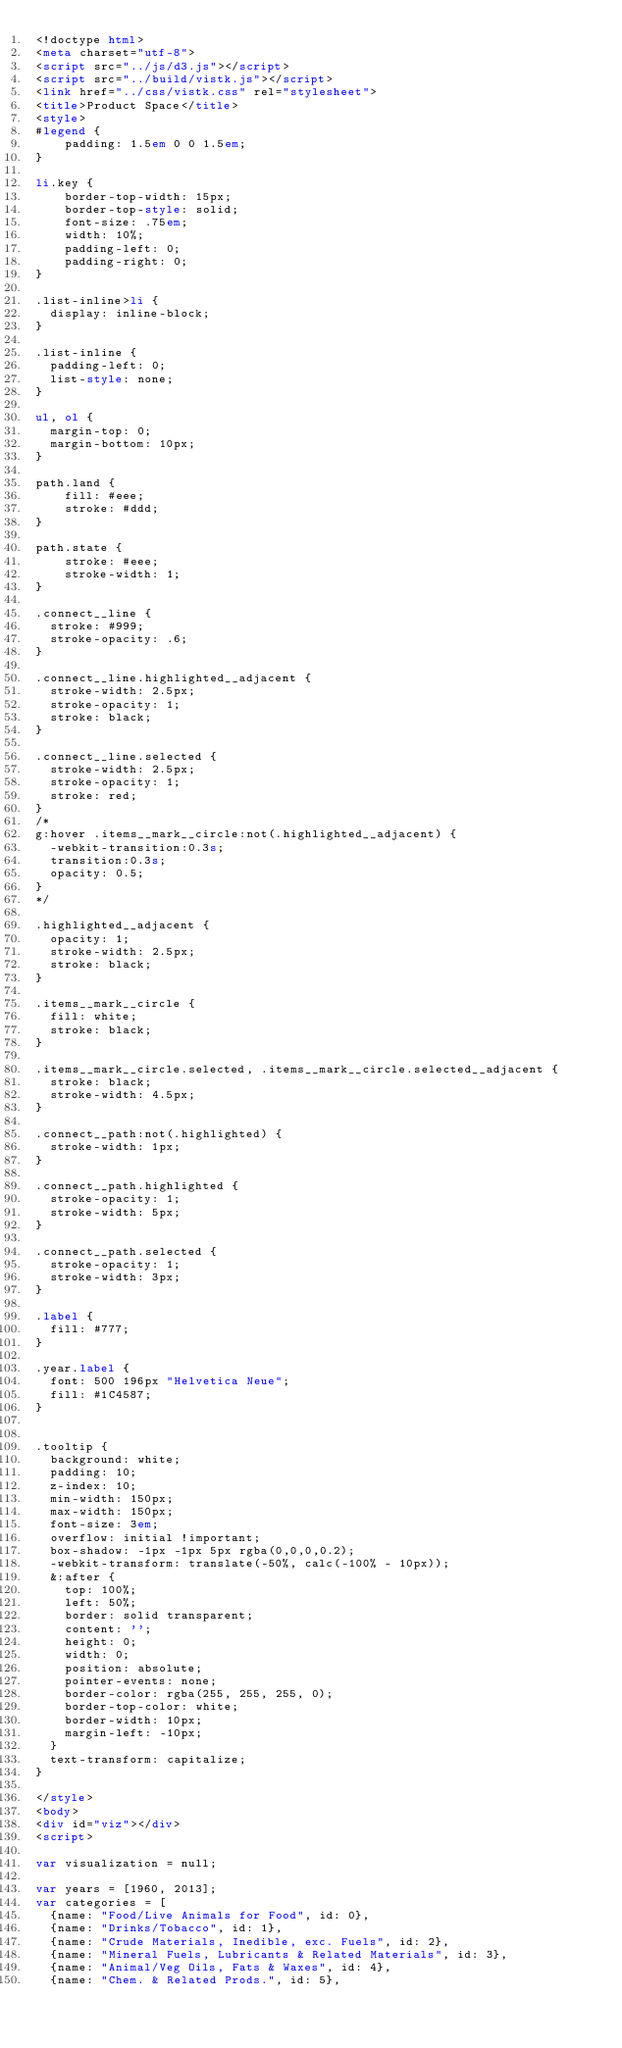Convert code to text. <code><loc_0><loc_0><loc_500><loc_500><_HTML_><!doctype html>
<meta charset="utf-8">
<script src="../js/d3.js"></script>
<script src="../build/vistk.js"></script>
<link href="../css/vistk.css" rel="stylesheet">
<title>Product Space</title>
<style>
#legend {
    padding: 1.5em 0 0 1.5em;
}

li.key {
    border-top-width: 15px;
    border-top-style: solid;
    font-size: .75em;
    width: 10%;
    padding-left: 0;
    padding-right: 0;
}

.list-inline>li {
  display: inline-block;
}

.list-inline {
  padding-left: 0;
  list-style: none;
}

ul, ol {
  margin-top: 0;
  margin-bottom: 10px;
}

path.land {
    fill: #eee;
    stroke: #ddd;
}

path.state {
    stroke: #eee;
    stroke-width: 1;
}

.connect__line {
  stroke: #999;
  stroke-opacity: .6;
}

.connect__line.highlighted__adjacent {
  stroke-width: 2.5px;
  stroke-opacity: 1;
  stroke: black;
}

.connect__line.selected {
  stroke-width: 2.5px;
  stroke-opacity: 1;
  stroke: red;
}
/*
g:hover .items__mark__circle:not(.highlighted__adjacent) {
  -webkit-transition:0.3s;
  transition:0.3s;
  opacity: 0.5;
}
*/

.highlighted__adjacent {
  opacity: 1;
  stroke-width: 2.5px;
  stroke: black;
}

.items__mark__circle {
  fill: white;
  stroke: black;
}

.items__mark__circle.selected, .items__mark__circle.selected__adjacent {
  stroke: black;
  stroke-width: 4.5px;
}

.connect__path:not(.highlighted) {
  stroke-width: 1px;
}

.connect__path.highlighted {
  stroke-opacity: 1;
  stroke-width: 5px;
}

.connect__path.selected {
  stroke-opacity: 1;
  stroke-width: 3px;
}

.label {
  fill: #777;
}

.year.label {
  font: 500 196px "Helvetica Neue";
  fill: #1C4587;
}


.tooltip {
  background: white;
  padding: 10;
  z-index: 10;
  min-width: 150px;
  max-width: 150px;
  font-size: 3em;
  overflow: initial !important;
  box-shadow: -1px -1px 5px rgba(0,0,0,0.2);
  -webkit-transform: translate(-50%, calc(-100% - 10px));
  &:after {
    top: 100%;
    left: 50%;
    border: solid transparent;
    content: '';
    height: 0;
    width: 0;
    position: absolute;
    pointer-events: none;
    border-color: rgba(255, 255, 255, 0);
    border-top-color: white;
    border-width: 10px;
    margin-left: -10px;
  }
  text-transform: capitalize;
}

</style>
<body>
<div id="viz"></div>
<script>

var visualization = null;

var years = [1960, 2013];
var categories = [
  {name: "Food/Live Animals for Food", id: 0},
  {name: "Drinks/Tobacco", id: 1},
  {name: "Crude Materials, Inedible, exc. Fuels", id: 2},
  {name: "Mineral Fuels, Lubricants & Related Materials", id: 3},
  {name: "Animal/Veg Oils, Fats & Waxes", id: 4},
  {name: "Chem. & Related Prods.", id: 5},</code> 